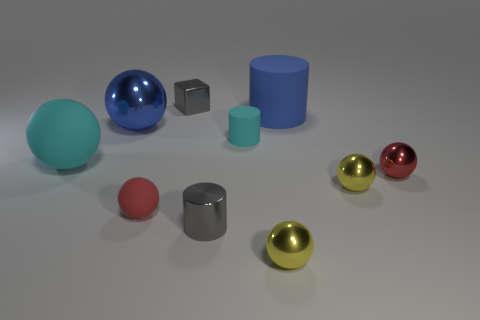Subtract all cyan spheres. How many spheres are left? 5 Subtract all big matte balls. How many balls are left? 5 Subtract all cyan spheres. Subtract all brown blocks. How many spheres are left? 5 Subtract all balls. How many objects are left? 4 Add 1 tiny gray metal blocks. How many tiny gray metal blocks are left? 2 Add 4 cyan balls. How many cyan balls exist? 5 Subtract 0 red cubes. How many objects are left? 10 Subtract all large cylinders. Subtract all large blue shiny spheres. How many objects are left? 8 